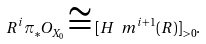<formula> <loc_0><loc_0><loc_500><loc_500>R ^ { i } \pi _ { * } O _ { X _ { 0 } } \cong [ H _ { \ } m ^ { i + 1 } ( R ) ] _ { > 0 } .</formula> 